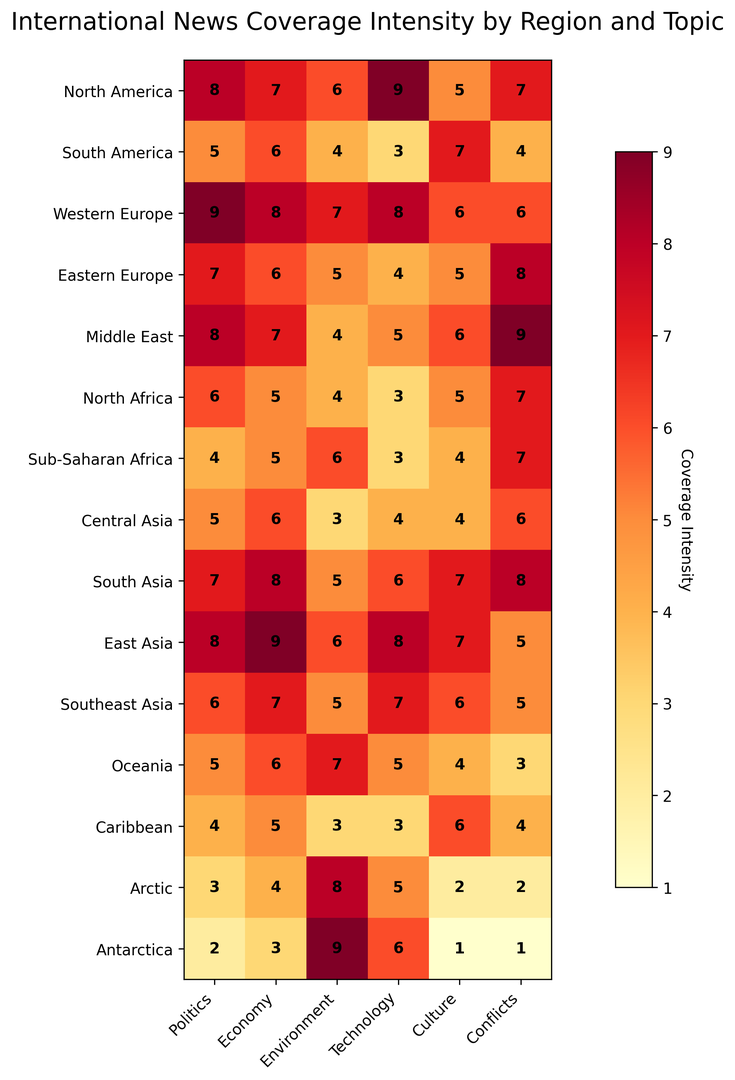Who has the highest news coverage intensity for Technology? We need to look at the column labeled "Technology" and identify the region with the highest value. The highest value is 9 in East Asia.
Answer: East Asia Which region has the lowest coverage intensity for Environment? To determine this, we examine the "Environment" column and identify the lowest value, which is 3, found in both South America and North Africa.
Answer: South America, North Africa Compare the news coverage intensity for Politics between North America and Western Europe. Which has higher coverage? We check the "Politics" column for both North America and Western Europe. North America has 8 and Western Europe has 9. Western Europe has higher coverage.
Answer: Western Europe What is the average news coverage intensity for Sub-Saharan Africa across all topics? We need to sum all the values for Sub-Saharan Africa across the topics (4 + 5 + 6 + 3 + 4 + 7 = 29) and divide by the number of topics (6). The average is 29/6 = 4.83.
Answer: 4.83 Which regions have equal news coverage intensity for Conflicts? By examining the "Conflicts" column, we find that North America, North Africa, and Sub-Saharan Africa all have a value of 7.
Answer: North America, North Africa, Sub-Saharan Africa What is the difference in coverage intensity for Culture between Southeast Asia and Oceania? Look at the "Culture" column for Southeast Asia (6) and Oceania (4). The difference is 6 - 4 = 2.
Answer: 2 Identify the region-topic pair with the highest news coverage intensity. We need to scan the entire heatmap for the highest value, which is 9. It is found in Western Europe for Politics and East Asia for Technology.
Answer: Western Europe-Politics, East Asia-Technology Which region has the most balanced news coverage across all topics (i.e., the smallest range between highest and lowest)? Calculate the range (difference between max and min values) for each region. For example, North America has a range of 9-5=4. The region with the smallest range is Western Europe, with a range of 9-6=3.
Answer: Western Europe How does the news coverage intensity for Economy in the Middle East compare to South Asia? The "Economy" column shows Middle East with a 7 and South Asia with an 8. South Asia has a higher intensity.
Answer: South Asia 